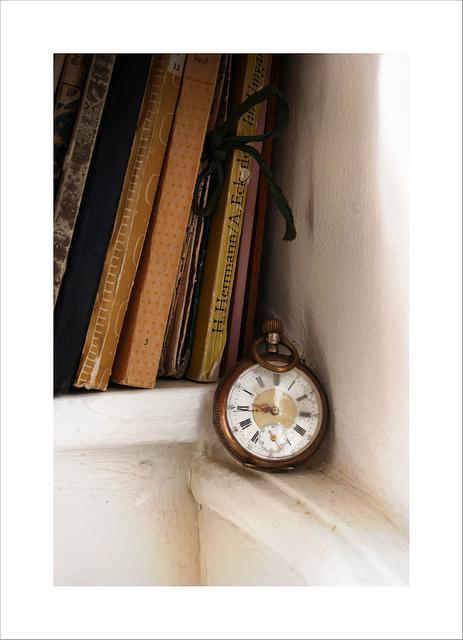How many books are there?
Give a very brief answer. 8. How many people are wearing yellow?
Give a very brief answer. 0. 